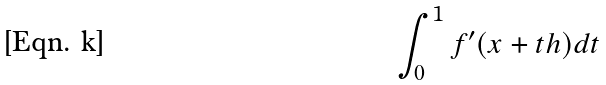Convert formula to latex. <formula><loc_0><loc_0><loc_500><loc_500>\int _ { 0 } ^ { 1 } f ^ { \prime } ( x + t h ) d t</formula> 